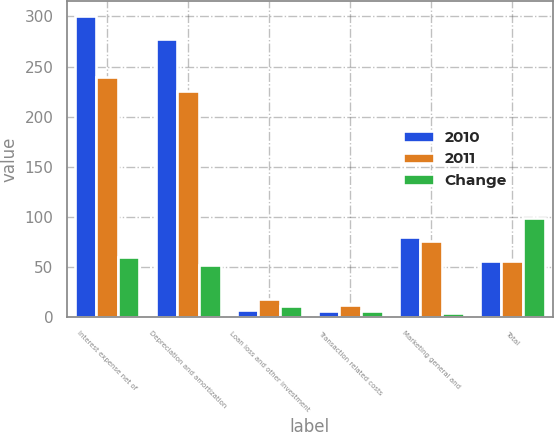<chart> <loc_0><loc_0><loc_500><loc_500><stacked_bar_chart><ecel><fcel>Interest expense net of<fcel>Depreciation and amortization<fcel>Loan loss and other investment<fcel>Transaction related costs<fcel>Marketing general and<fcel>Total<nl><fcel>2010<fcel>300<fcel>277.3<fcel>6.7<fcel>5.6<fcel>80.1<fcel>56.2<nl><fcel>2011<fcel>239.7<fcel>225.2<fcel>17.8<fcel>11.8<fcel>75.9<fcel>56.2<nl><fcel>Change<fcel>60.3<fcel>52.1<fcel>11.1<fcel>6.2<fcel>4.2<fcel>99.3<nl></chart> 